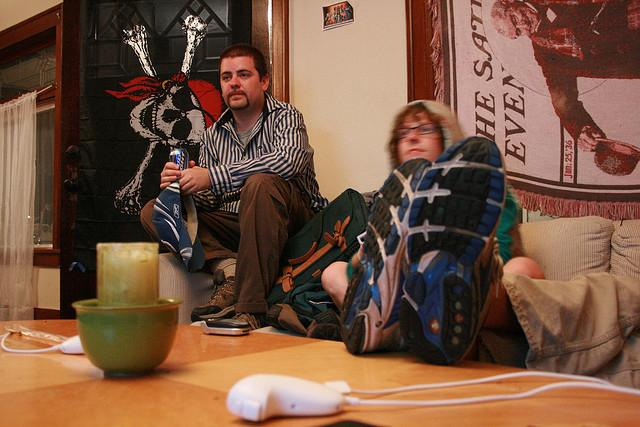What is the man on the left drinking? Please explain your reasoning. beer. The man on the left is drinking a can of beer. 